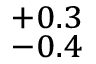<formula> <loc_0><loc_0><loc_500><loc_500>^ { + 0 . 3 } _ { - 0 . 4 }</formula> 